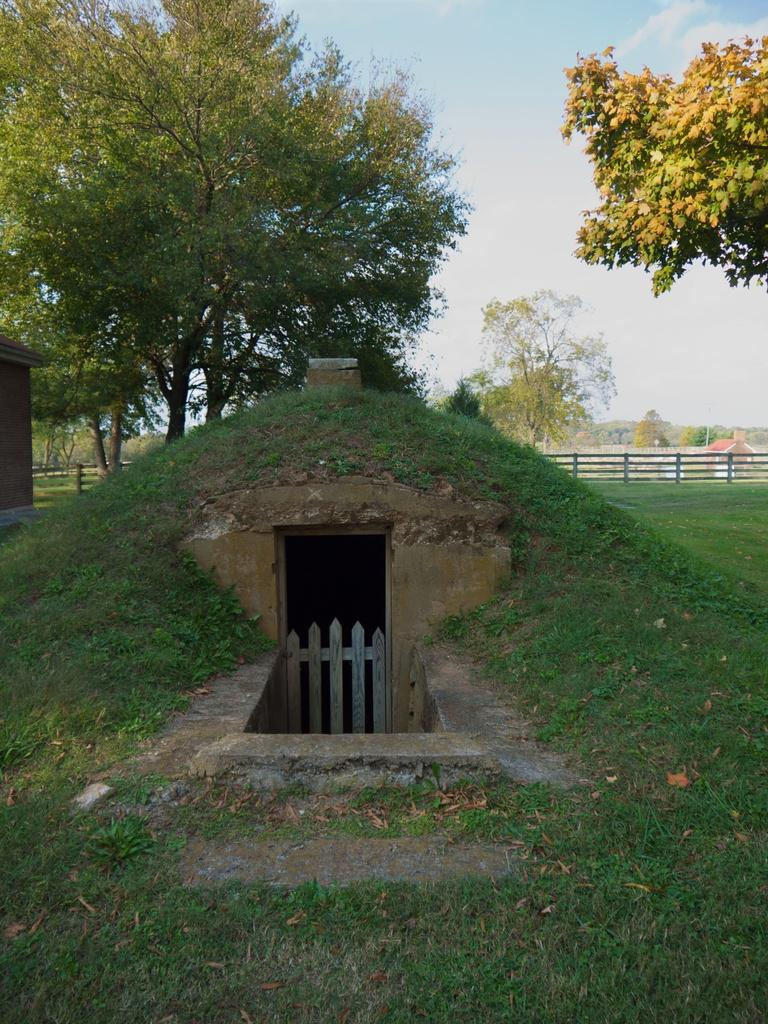What is the main feature in the center of the image? There is a cave in the center of the image. What is in front of the cave? There is a gate in front of the cave. What can be seen in the background of the image? There are sheds, trees, and a fence in the background of the image. What is visible in the sky at the top of the image? There are clouds visible in the sky at the top of the image. What type of potato is being used as a security guard for the cave in the image? There is no potato present in the image, and therefore no such security guard can be observed. 